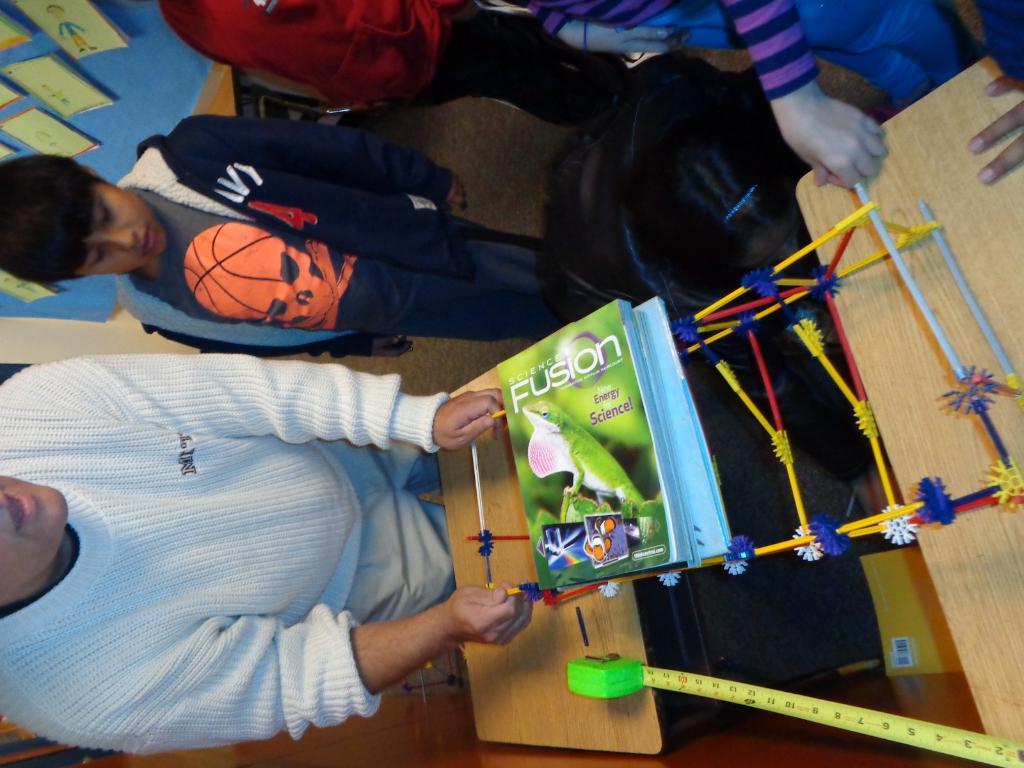Describe this image in one or two sentences. In this picture there are two tables in the image, on which, it seems to be a fusion book and a measuring tape on the tables, there are people those who are standing around the tables and there are posters in the background area of the image. 